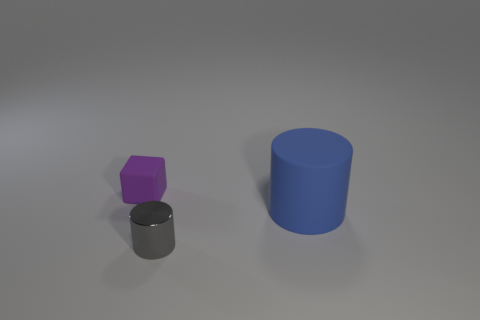Is there any other thing that is the same material as the gray thing?
Your response must be concise. No. What number of tiny rubber cylinders are there?
Make the answer very short. 0. Do the big object and the object to the left of the shiny object have the same shape?
Ensure brevity in your answer.  No. Is the number of small things that are in front of the blue matte thing less than the number of tiny gray metal cylinders that are in front of the gray cylinder?
Your response must be concise. No. Are there any other things that are the same shape as the large blue thing?
Provide a short and direct response. Yes. Does the blue matte object have the same shape as the tiny purple thing?
Your response must be concise. No. The blue object has what size?
Give a very brief answer. Large. What color is the thing that is both behind the small gray cylinder and on the right side of the small purple matte block?
Give a very brief answer. Blue. Is the number of large red metallic balls greater than the number of big rubber objects?
Provide a short and direct response. No. How many things are blocks or objects that are left of the gray thing?
Your response must be concise. 1. 